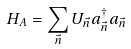Convert formula to latex. <formula><loc_0><loc_0><loc_500><loc_500>H _ { A } = \sum _ { \vec { n } } U _ { \vec { n } } a ^ { \dagger } _ { \vec { n } } a _ { \vec { n } }</formula> 